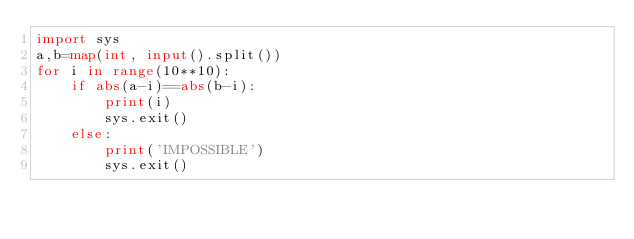Convert code to text. <code><loc_0><loc_0><loc_500><loc_500><_Python_>import sys
a,b=map(int, input().split())
for i in range(10**10):
    if abs(a-i)==abs(b-i):
        print(i)
        sys.exit()
    else:
        print('IMPOSSIBLE')
        sys.exit()</code> 